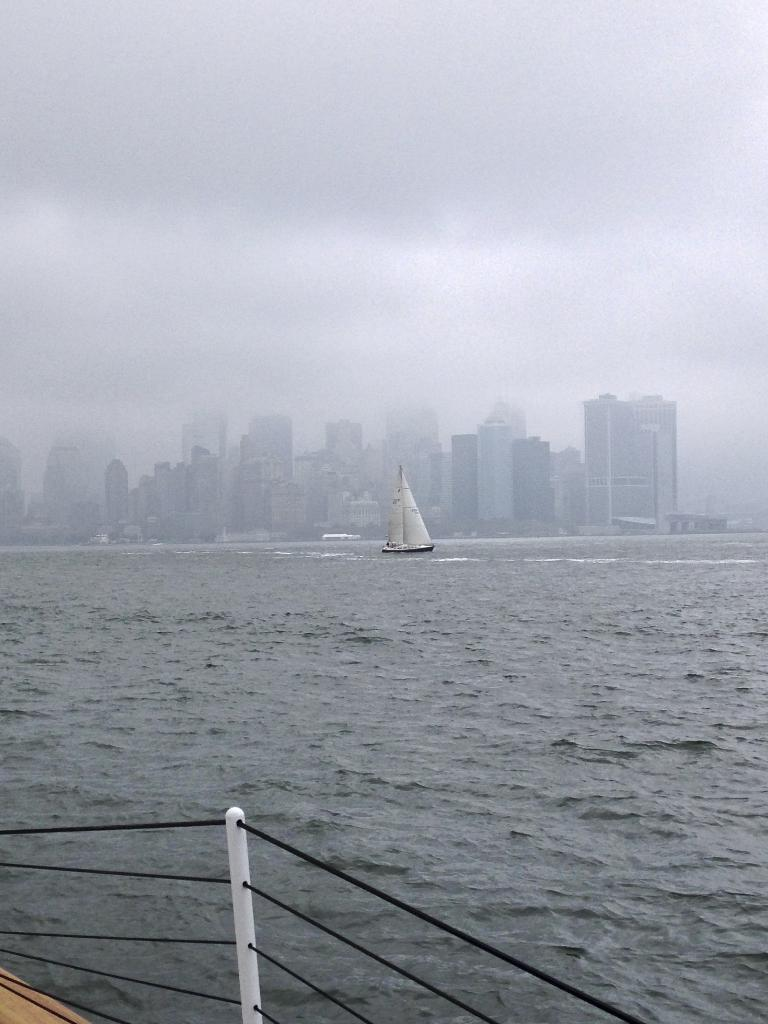What is located at the bottom of the image? There is water at the bottom of the image. What can be seen in the middle of the image? There is a boat in the middle of the image. What type of structures are visible in the background of the image? There are buildings in the background of the image. What is visible at the top of the image? The sky is visible at the top of the image. What type of bait is being used by the fish in the image? There are no fish or bait present in the image; it features a boat on water with buildings in the background and a visible sky. 